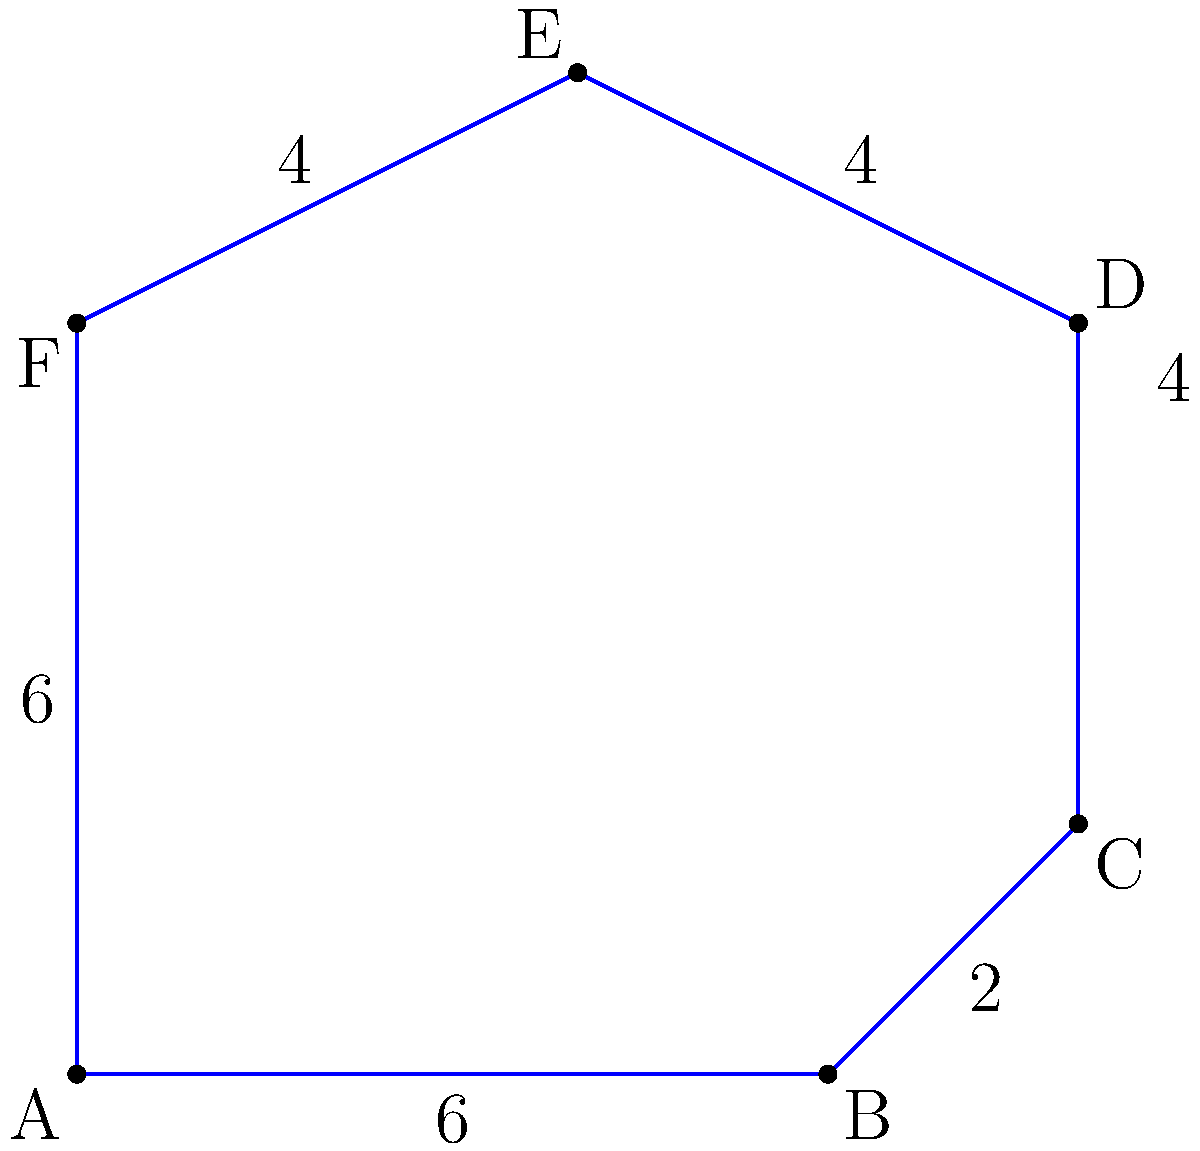As a mobile application developer, you're implementing a geofencing feature for a location-based service. The geofenced region is represented by the complex polygon ABCDEF shown in the diagram. Calculate the area of this polygon to determine the coverage of your geofenced region. All measurements are in kilometers. To calculate the area of this complex polygon, we'll use the shoelace formula (also known as the surveyor's formula). Here's the step-by-step process:

1) The shoelace formula for a polygon with vertices $(x_1, y_1), (x_2, y_2), ..., (x_n, y_n)$ is:

   Area = $\frac{1}{2}|((x_1y_2 + x_2y_3 + ... + x_ny_1) - (y_1x_2 + y_2x_3 + ... + y_nx_1))|$

2) Let's assign coordinates to our vertices:
   A(0,0), B(6,0), C(8,2), D(8,6), E(4,8), F(0,6)

3) Now, let's apply the formula:

   Area = $\frac{1}{2}|((0\cdot0 + 6\cdot2 + 8\cdot6 + 8\cdot8 + 4\cdot6 + 0\cdot0) - (0\cdot6 + 0\cdot8 + 2\cdot8 + 6\cdot4 + 8\cdot0 + 6\cdot0))|$

4) Simplify:
   Area = $\frac{1}{2}|((0 + 12 + 48 + 64 + 24 + 0) - (0 + 0 + 16 + 24 + 0 + 0))|$
   Area = $\frac{1}{2}|(148 - 40)|$
   Area = $\frac{1}{2}(108)$
   Area = 54

Therefore, the area of the geofenced region is 54 square kilometers.
Answer: 54 km² 